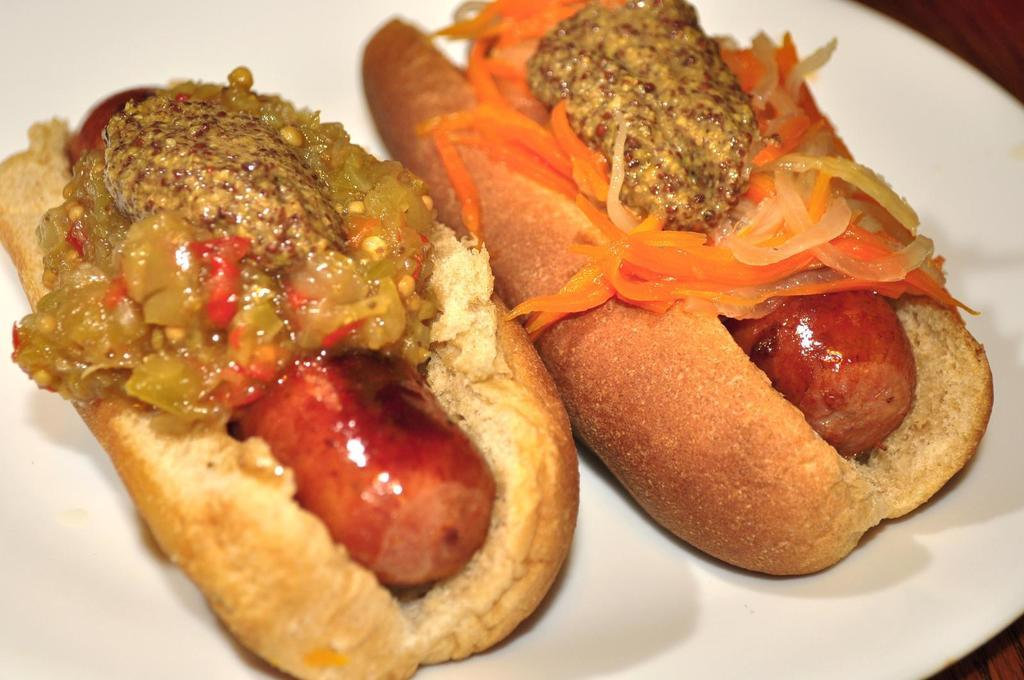What is the color of the plate in the image? The plate in the image is white. What is on the plate? The plate contains a chili hot dog. What type of bird is singing on the lamp in the image? There is no bird or lamp present in the image; it only features a white plate with a chili hot dog. 